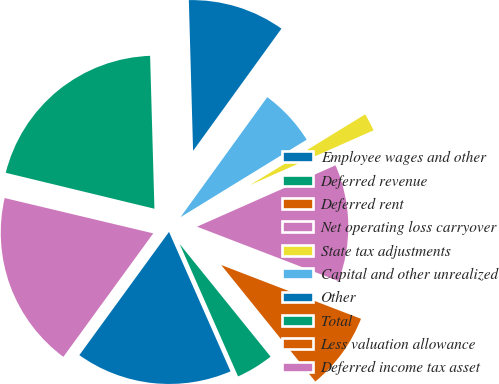Convert chart to OTSL. <chart><loc_0><loc_0><loc_500><loc_500><pie_chart><fcel>Employee wages and other<fcel>Deferred revenue<fcel>Deferred rent<fcel>Net operating loss carryover<fcel>State tax adjustments<fcel>Capital and other unrealized<fcel>Other<fcel>Total<fcel>Less valuation allowance<fcel>Deferred income tax asset<nl><fcel>16.62%<fcel>4.2%<fcel>8.34%<fcel>12.48%<fcel>2.13%<fcel>6.27%<fcel>10.41%<fcel>20.77%<fcel>0.06%<fcel>18.7%<nl></chart> 